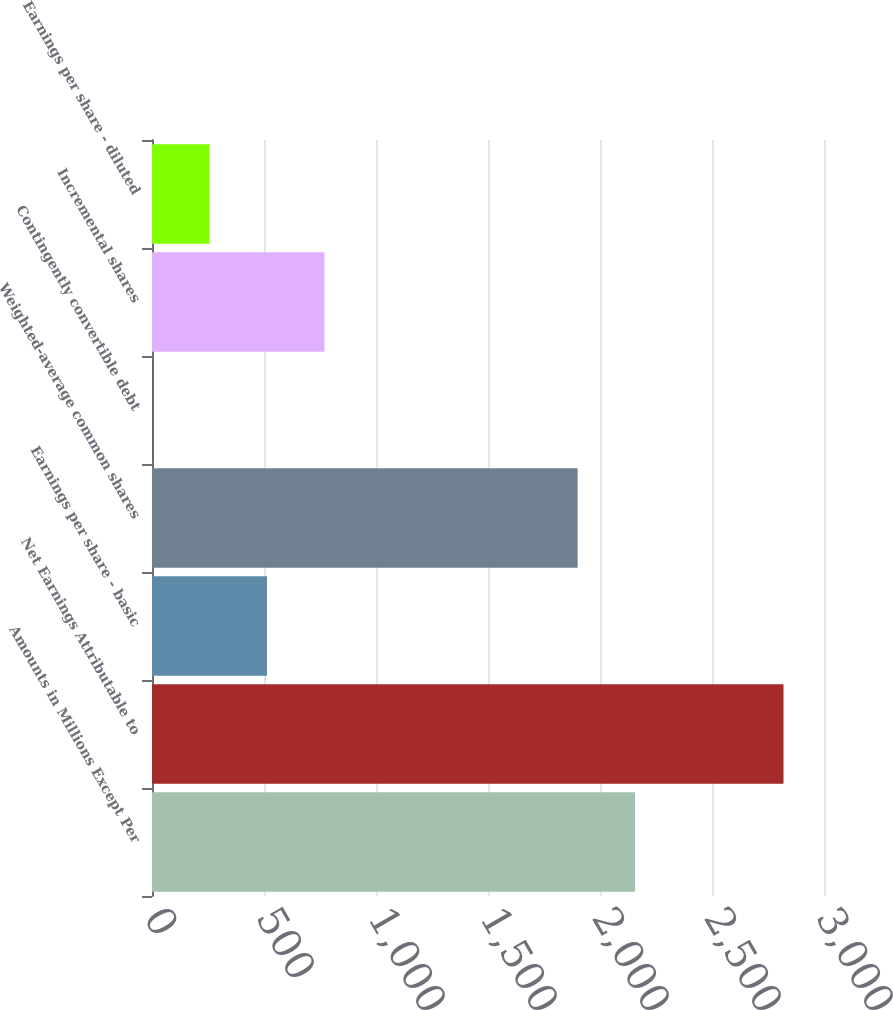Convert chart to OTSL. <chart><loc_0><loc_0><loc_500><loc_500><bar_chart><fcel>Amounts in Millions Except Per<fcel>Net Earnings Attributable to<fcel>Earnings per share - basic<fcel>Weighted-average common shares<fcel>Contingently convertible debt<fcel>Incremental shares<fcel>Earnings per share - diluted<nl><fcel>2156.4<fcel>2819.2<fcel>513.4<fcel>1900.2<fcel>1<fcel>769.6<fcel>257.2<nl></chart> 